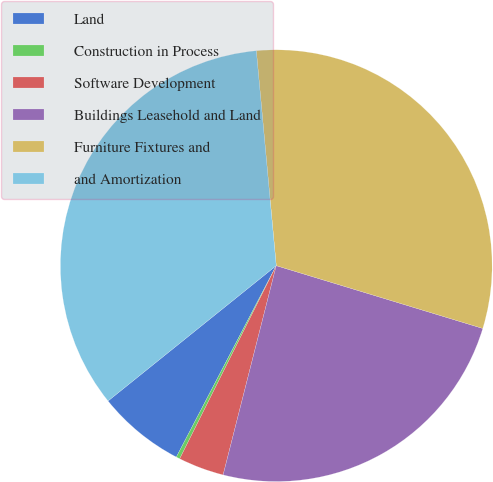<chart> <loc_0><loc_0><loc_500><loc_500><pie_chart><fcel>Land<fcel>Construction in Process<fcel>Software Development<fcel>Buildings Leasehold and Land<fcel>Furniture Fixtures and<fcel>and Amortization<nl><fcel>6.56%<fcel>0.28%<fcel>3.42%<fcel>24.26%<fcel>31.17%<fcel>34.31%<nl></chart> 